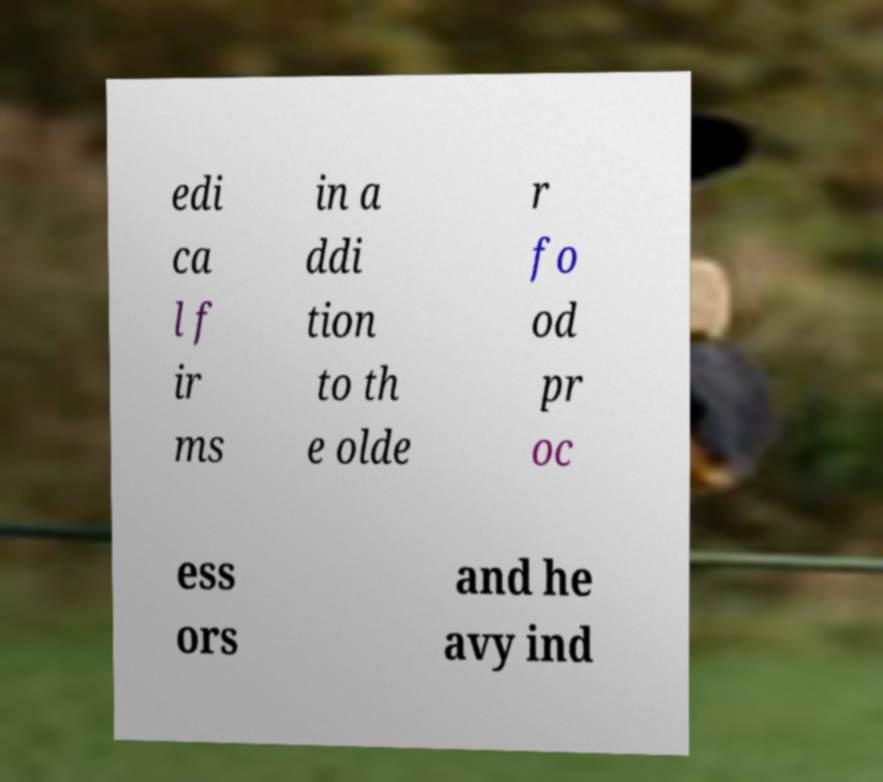For documentation purposes, I need the text within this image transcribed. Could you provide that? edi ca l f ir ms in a ddi tion to th e olde r fo od pr oc ess ors and he avy ind 